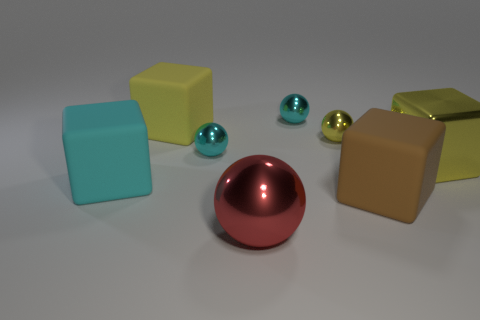How many total objects are there in the image? The image displays a total of eight objects, including cubes, spheres, and a cylinder. 